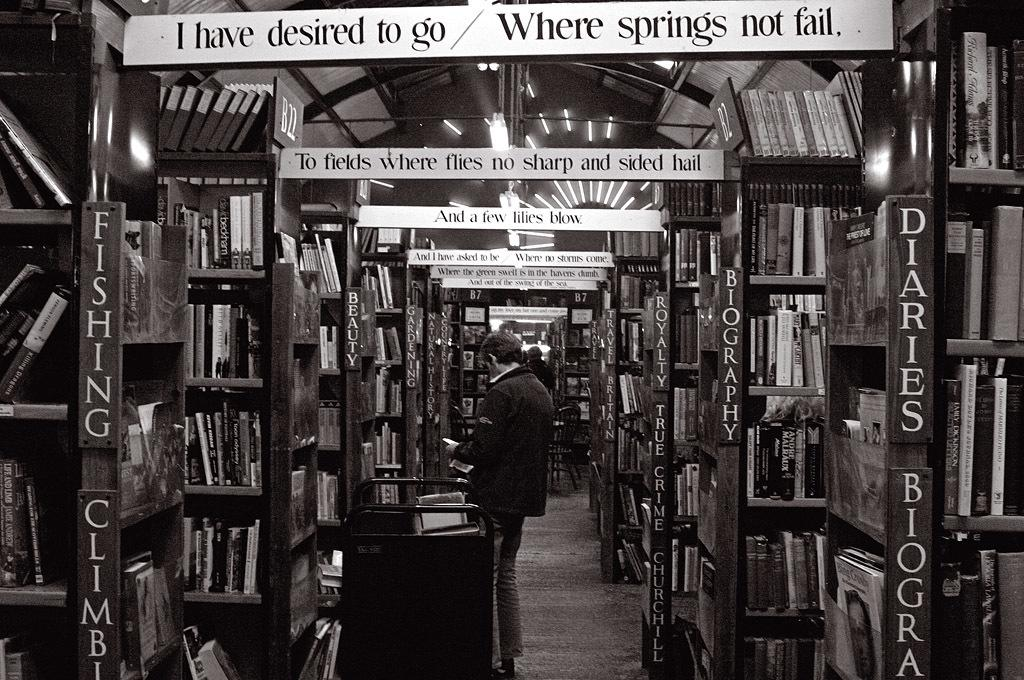<image>
Write a terse but informative summary of the picture. A library that offers diaries and fishing books. 